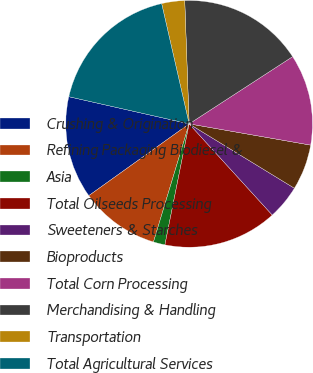Convert chart to OTSL. <chart><loc_0><loc_0><loc_500><loc_500><pie_chart><fcel>Crushing & Origination<fcel>Refining Packaging Biodiesel &<fcel>Asia<fcel>Total Oilseeds Processing<fcel>Sweeteners & Starches<fcel>Bioproducts<fcel>Total Corn Processing<fcel>Merchandising & Handling<fcel>Transportation<fcel>Total Agricultural Services<nl><fcel>13.42%<fcel>10.45%<fcel>1.52%<fcel>14.91%<fcel>4.5%<fcel>5.98%<fcel>11.93%<fcel>16.4%<fcel>3.01%<fcel>17.89%<nl></chart> 